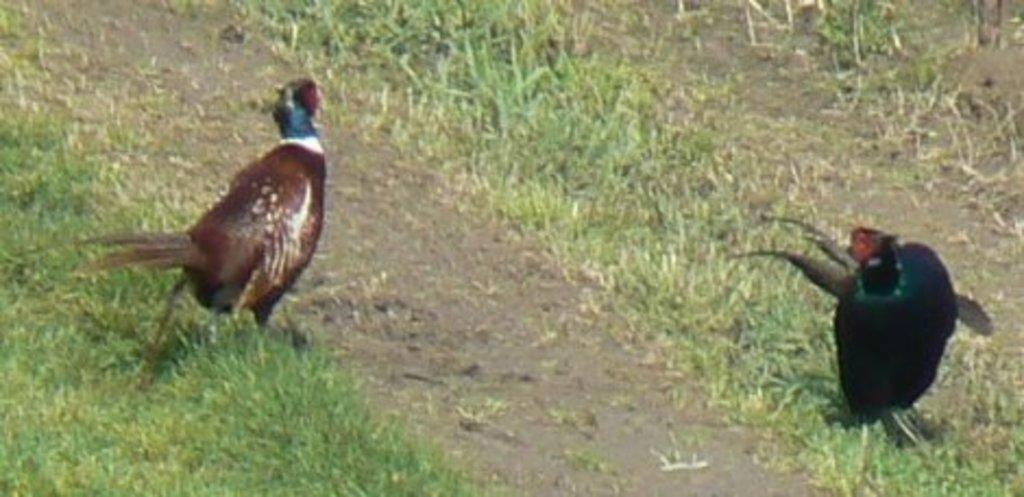How many birds are present in the image? There are two birds in the image. Where are the birds located? The birds are on the land. What type of vegetation is present on the land? The land has grass. What color is the leaf that the birds are sitting on in the image? There is no leaf present in the image; the birds are on the land with grass. 